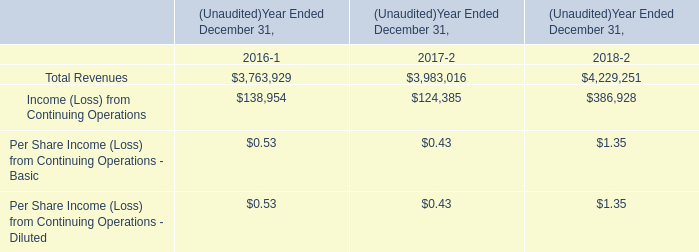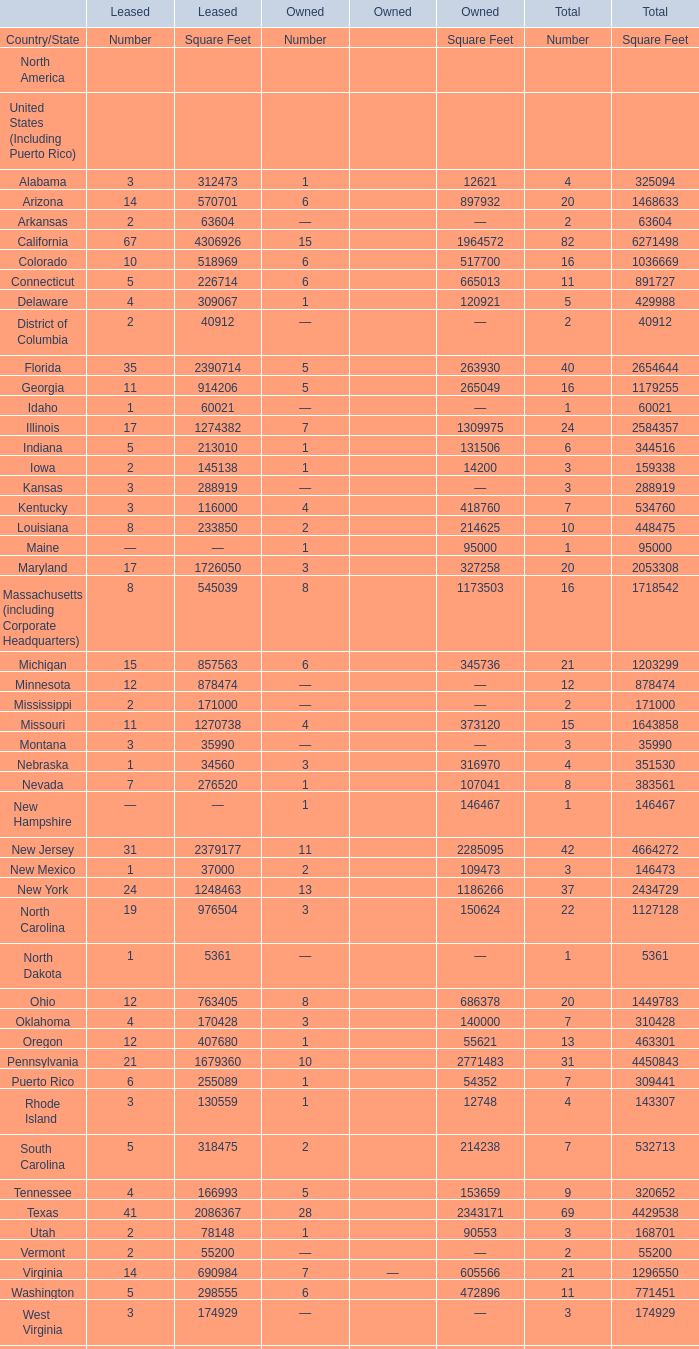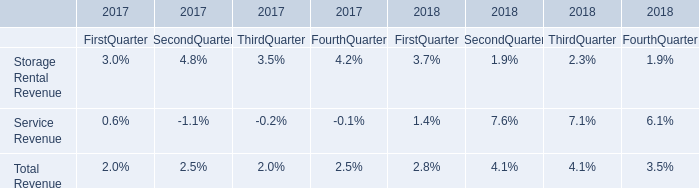What's the total value of all elements that are in the range of 4000000 and 5000000 for Square Feet of Total? 
Computations: (((4664272 + 4450843) + 4429538) + 4995129)
Answer: 18539782.0. 